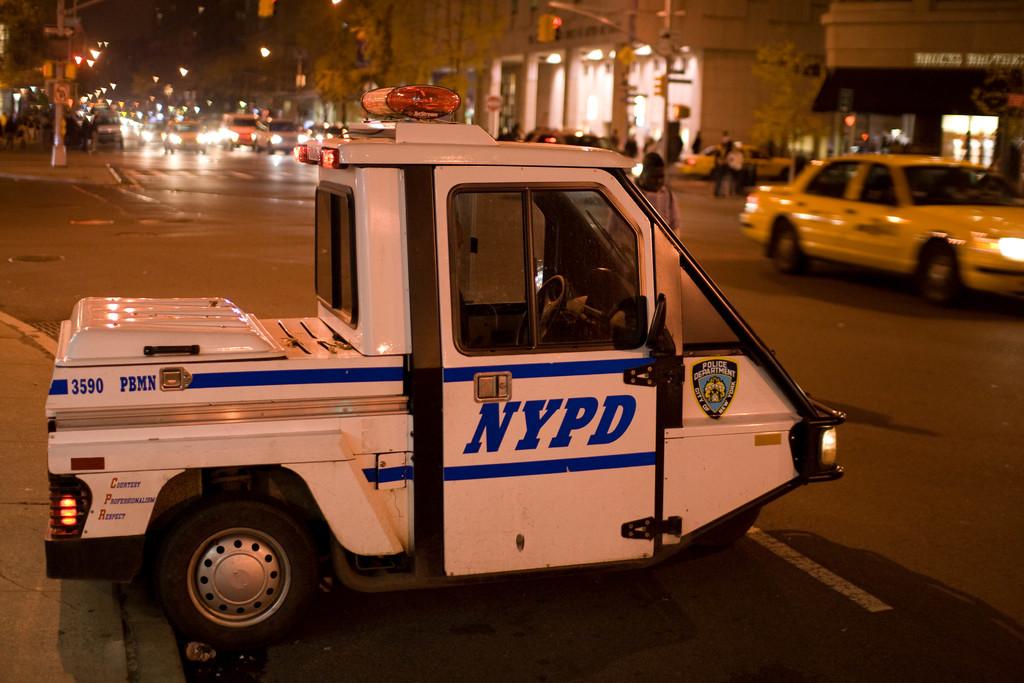Who does the truck belong to?
Ensure brevity in your answer.  Nypd. What city is being served?
Offer a terse response. New york. 